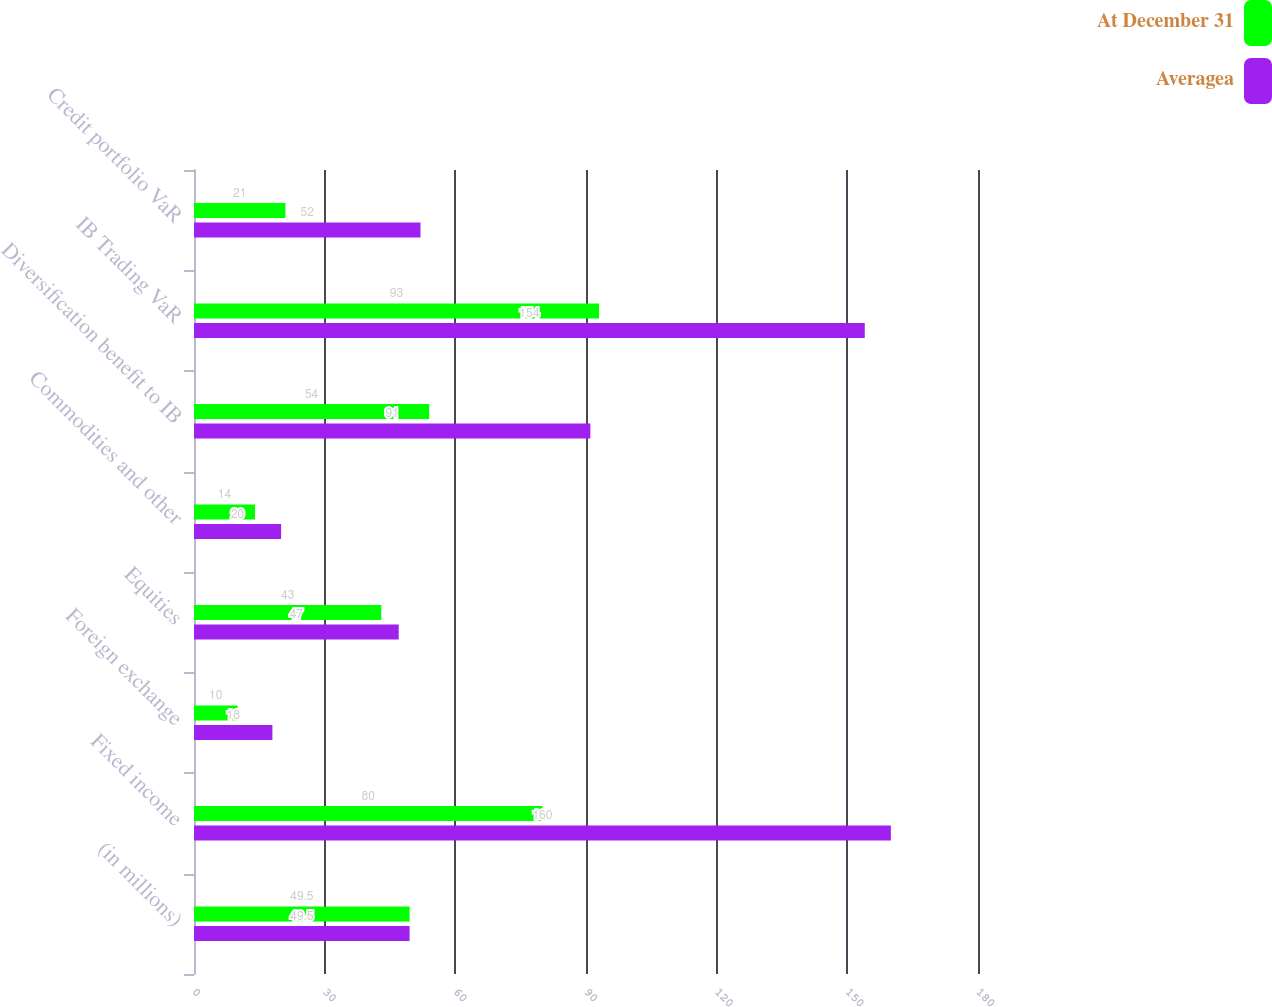Convert chart. <chart><loc_0><loc_0><loc_500><loc_500><stacked_bar_chart><ecel><fcel>(in millions)<fcel>Fixed income<fcel>Foreign exchange<fcel>Equities<fcel>Commodities and other<fcel>Diversification benefit to IB<fcel>IB Trading VaR<fcel>Credit portfolio VaR<nl><fcel>At December 31<fcel>49.5<fcel>80<fcel>10<fcel>43<fcel>14<fcel>54<fcel>93<fcel>21<nl><fcel>Averagea<fcel>49.5<fcel>160<fcel>18<fcel>47<fcel>20<fcel>91<fcel>154<fcel>52<nl></chart> 